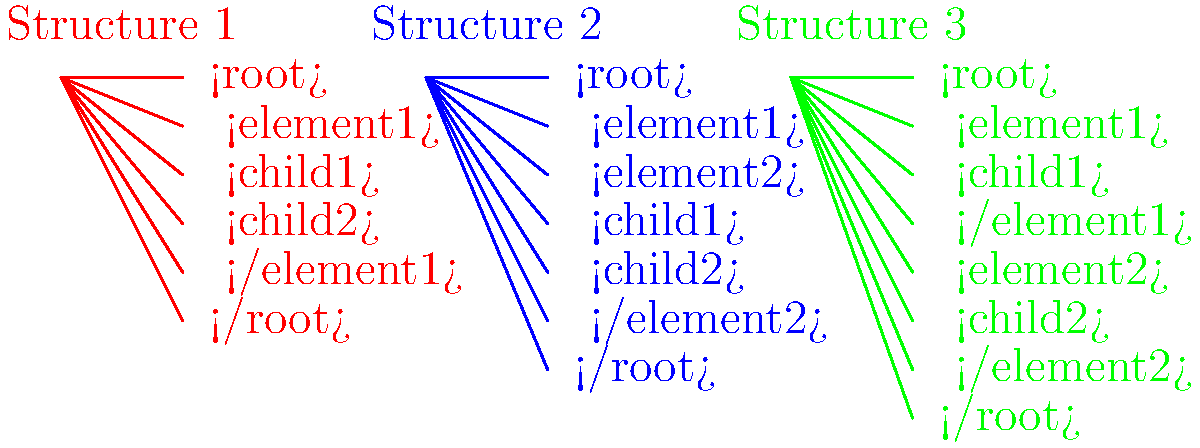Which XML document structure best adheres to the project requirement of having two separate elements under the root, each containing one child element? To determine which XML document structure best meets the given project requirement, let's analyze each structure:

1. Structure 1 (Red):
   - Has a single <element1> under the root
   - Contains two child elements (<child1> and <child2>) within <element1>
   - Does not meet the requirement of two separate elements under the root

2. Structure 2 (Blue):
   - Has two elements under the root (<element1> and <element2>)
   - Both child elements (<child1> and <child2>) are nested within <element2>
   - Does not meet the requirement of each element containing one child element

3. Structure 3 (Green):
   - Has two elements under the root (<element1> and <element2>)
   - <element1> contains <child1>
   - <element2> contains <child2>
   - Meets the requirement of two separate elements under the root, each containing one child element

Based on this analysis, Structure 3 (Green) best adheres to the project requirement of having two separate elements under the root, each containing one child element.
Answer: Structure 3 (Green) 